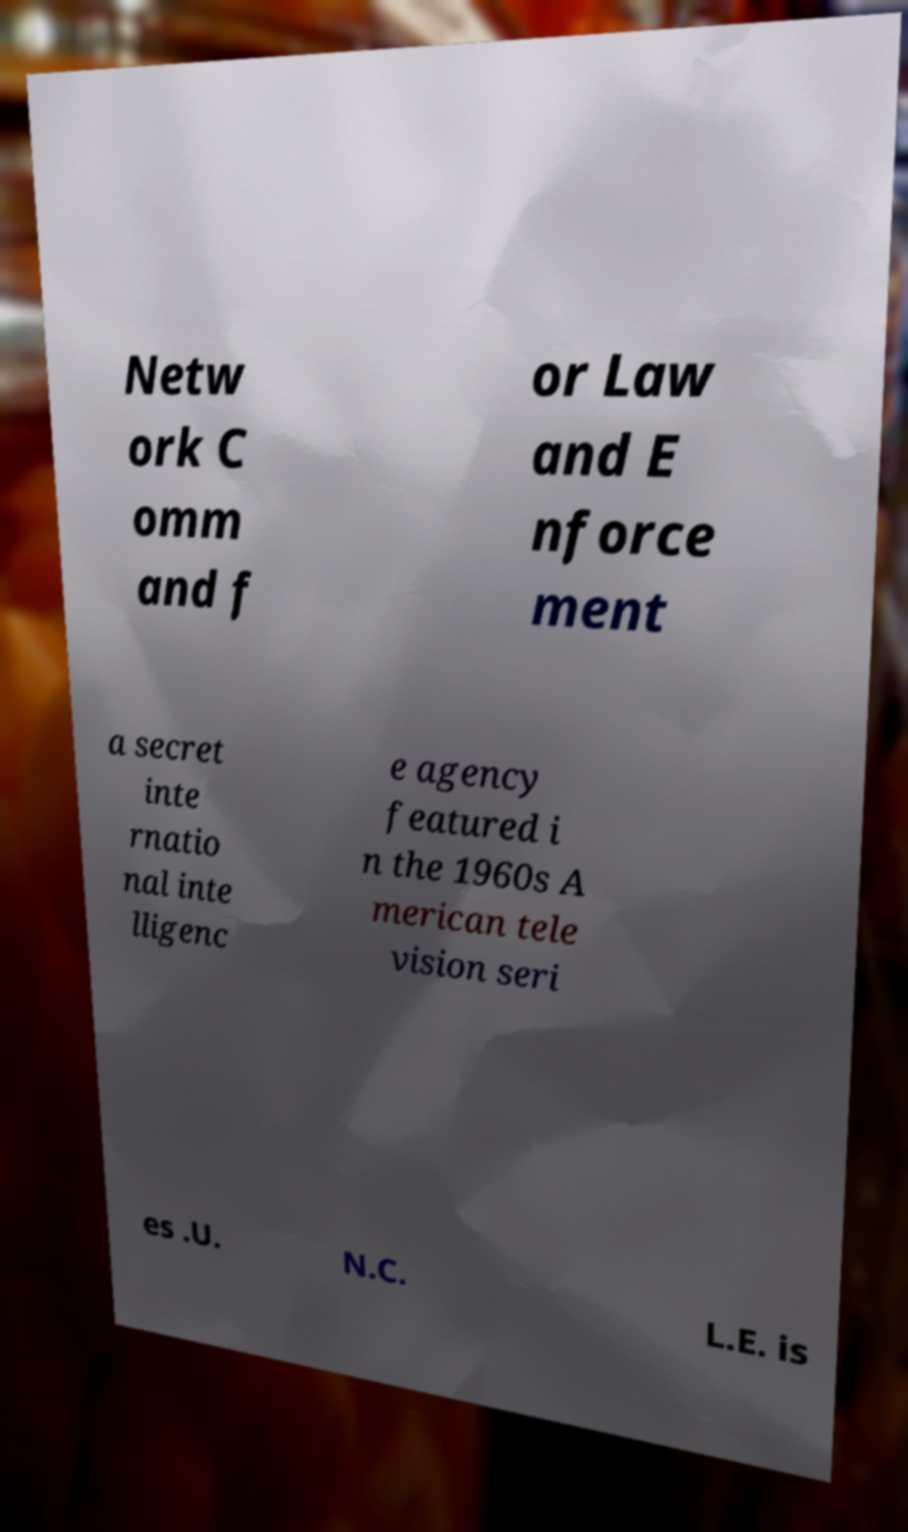Please identify and transcribe the text found in this image. Netw ork C omm and f or Law and E nforce ment a secret inte rnatio nal inte lligenc e agency featured i n the 1960s A merican tele vision seri es .U. N.C. L.E. is 